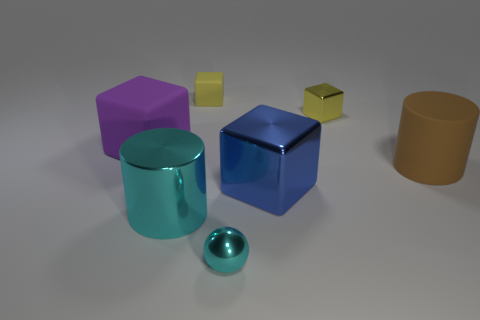There is another small thing that is the same shape as the small yellow rubber thing; what color is it?
Provide a short and direct response. Yellow. What size is the yellow matte thing?
Your answer should be compact. Small. What number of other objects have the same size as the brown thing?
Provide a short and direct response. 3. Does the tiny shiny cube have the same color as the big matte cylinder?
Provide a short and direct response. No. Is the material of the cyan thing that is behind the tiny cyan ball the same as the large block behind the blue block?
Your response must be concise. No. Is the number of large metallic cubes greater than the number of rubber objects?
Offer a very short reply. No. Are there any other things that have the same color as the small metallic block?
Provide a short and direct response. Yes. Are the large brown thing and the blue object made of the same material?
Keep it short and to the point. No. Are there fewer purple things than big green spheres?
Give a very brief answer. No. Does the blue thing have the same shape as the big purple thing?
Ensure brevity in your answer.  Yes. 